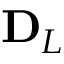<formula> <loc_0><loc_0><loc_500><loc_500>D _ { L }</formula> 